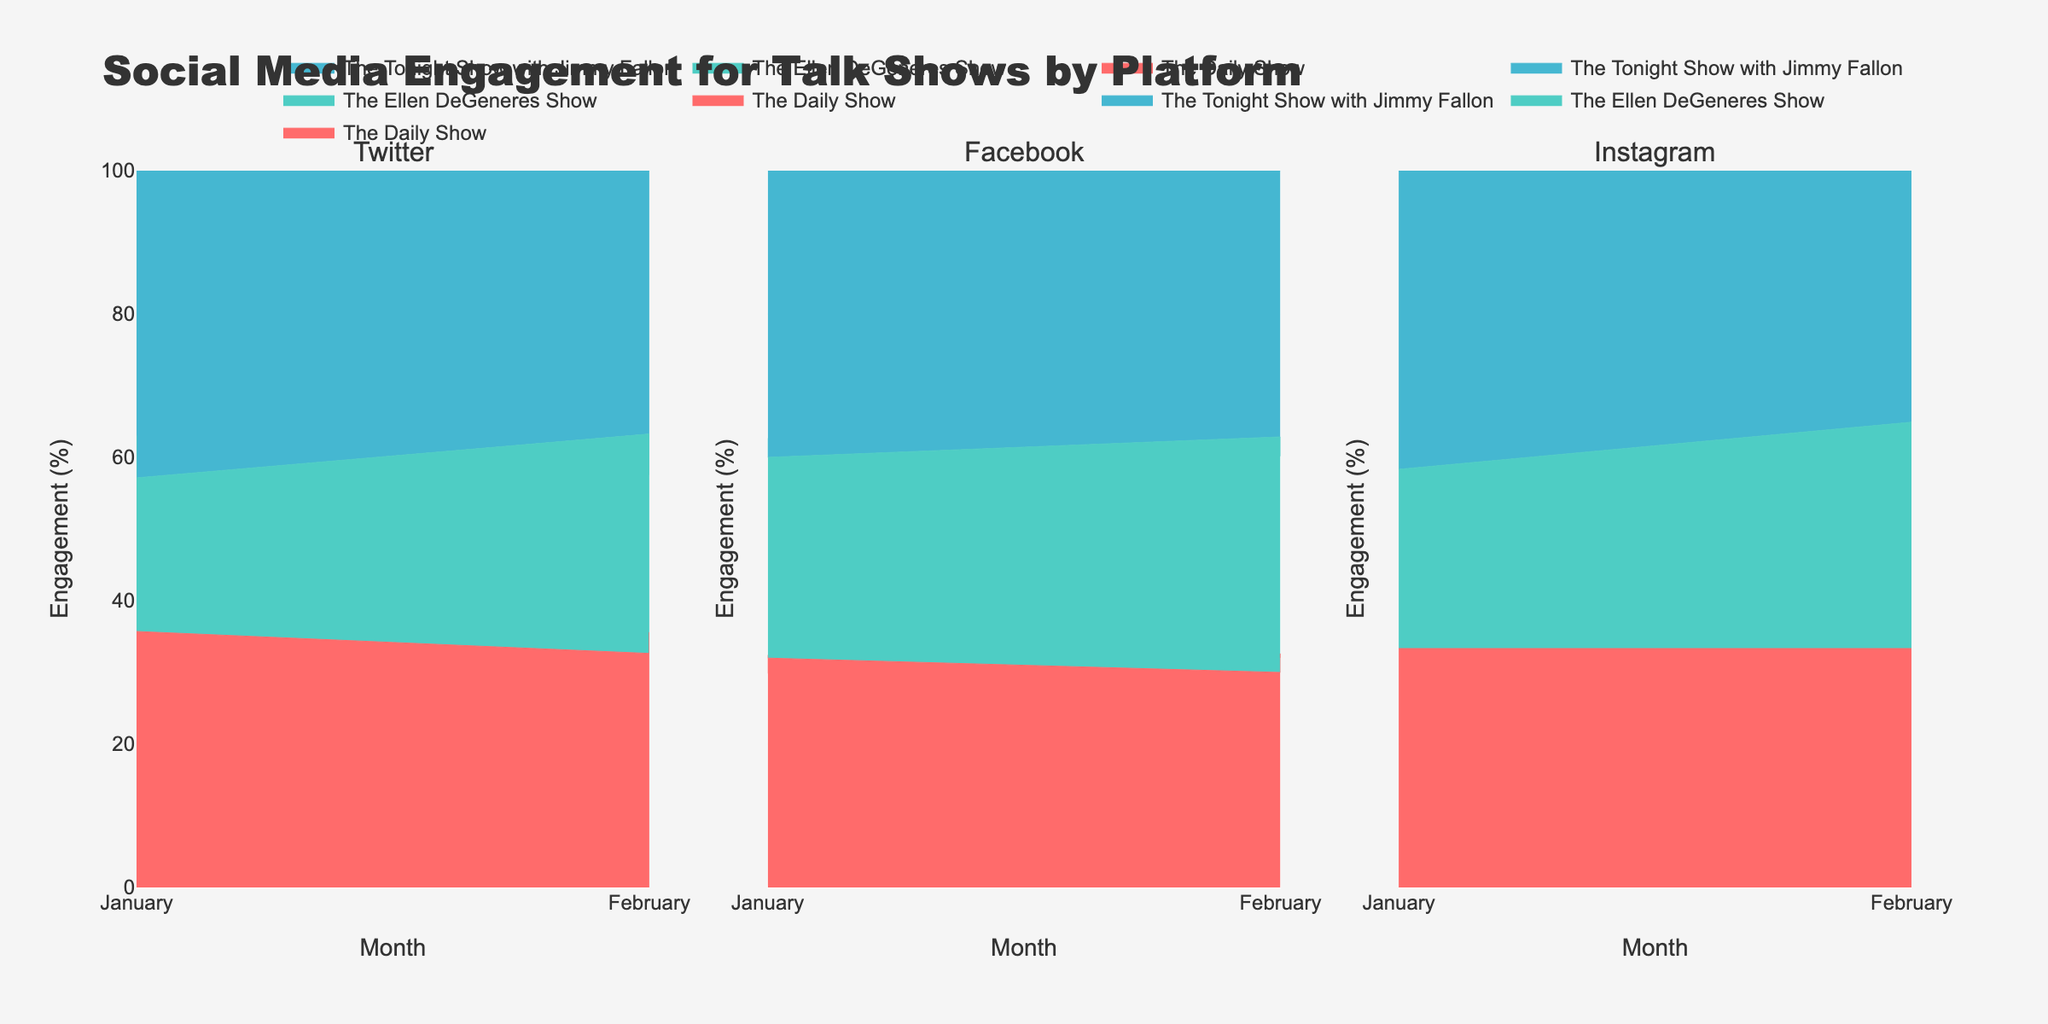What is the title of the figure? The title is located at the top of the figure and generally states the main subject or message the plot is showing. The title here summarizes the plot as "Social Media Engagement for Talk Shows by Platform"
Answer: Social Media Engagement for Talk Shows by Platform How many platforms are displayed in the figure? The subplot titles indicate the number of distinct platforms. Each subplot represents a different platform.
Answer: 3 Which show had the highest engagement on Facebook in January? To answer this, observe the area occupied by each show under "Facebook" in January. Compare the respective engagements.
Answer: The Tonight Show with Jimmy Fallon Between February and January, which show saw an increase in their Twitter likes engagement? Identify the figures related to Twitter in both January and February for each show. Compare the values to see the change.
Answer: The Daily Show Which engagement type is not present in Twitter data? Examine the engagement types shown for Twitter compared to other platforms. Unlike Facebook and Instagram, Twitter doesn't show a specific engagement type.
Answer: Shares What percentage of engagement did "The Ellen DeGeneres Show" receive on Instagram in February? Review the stacked area for "The Ellen DeGeneres Show" on Instagram in February to estimate its share. Given it is a percentage area chart, visually assess the percentage.
Answer: Approximately 35% Comparing January and February, which platform showed the most consistent engagement for "The Daily Show"? Consistent engagement means little variation between January and February. Compare "The Daily Show" totals across all engagement types and both months.
Answer: Facebook Did "The Tonight Show with Jimmy Fallon" have more total engagement on Twitter or Facebook in February? Check the stacked area sizes in the February subplot for each platform, summing the engagements to compare totals.
Answer: Facebook Which talk show had the lowest comments engagement on Instagram in January? Look at the area corresponding to comments for each show on Instagram for January, and identify the smallest area.
Answer: The Ellen DeGeneres Show 